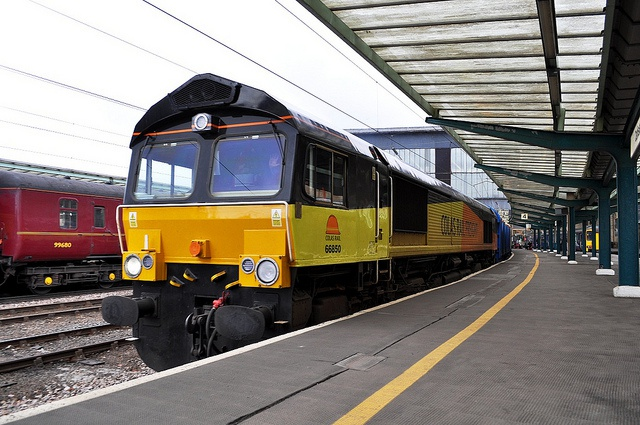Describe the objects in this image and their specific colors. I can see train in white, black, orange, and gray tones, train in white, maroon, black, gray, and brown tones, and people in white and gray tones in this image. 